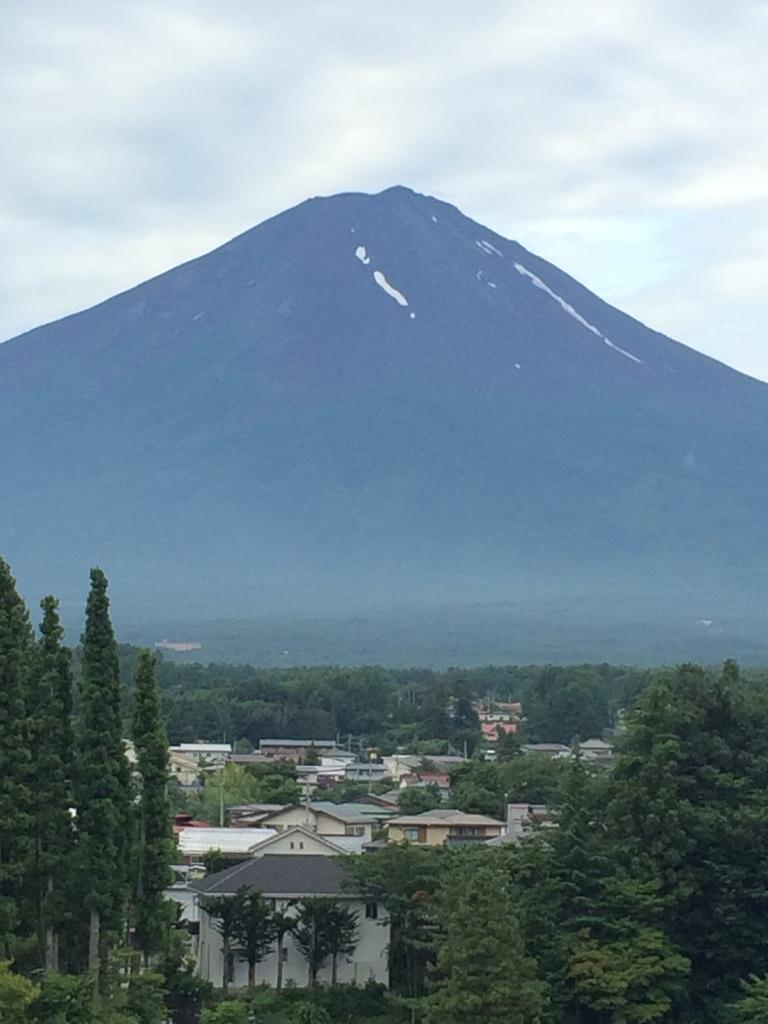Where was the image taken? The image was taken in a town. What can be seen in the foreground of the image? There are trees and buildings in the foreground of the image. What is located in the center of the background of the image? There is a mountain in the center of the background of the image. What is the condition of the sky in the image? The sky is cloudy in the image. How many beef dishes can be seen on the table in the image? There is no table or beef dishes present in the image. What type of spiders are crawling on the buildings in the image? There are no spiders visible in the image; it features a town with trees, buildings, and a mountain. 